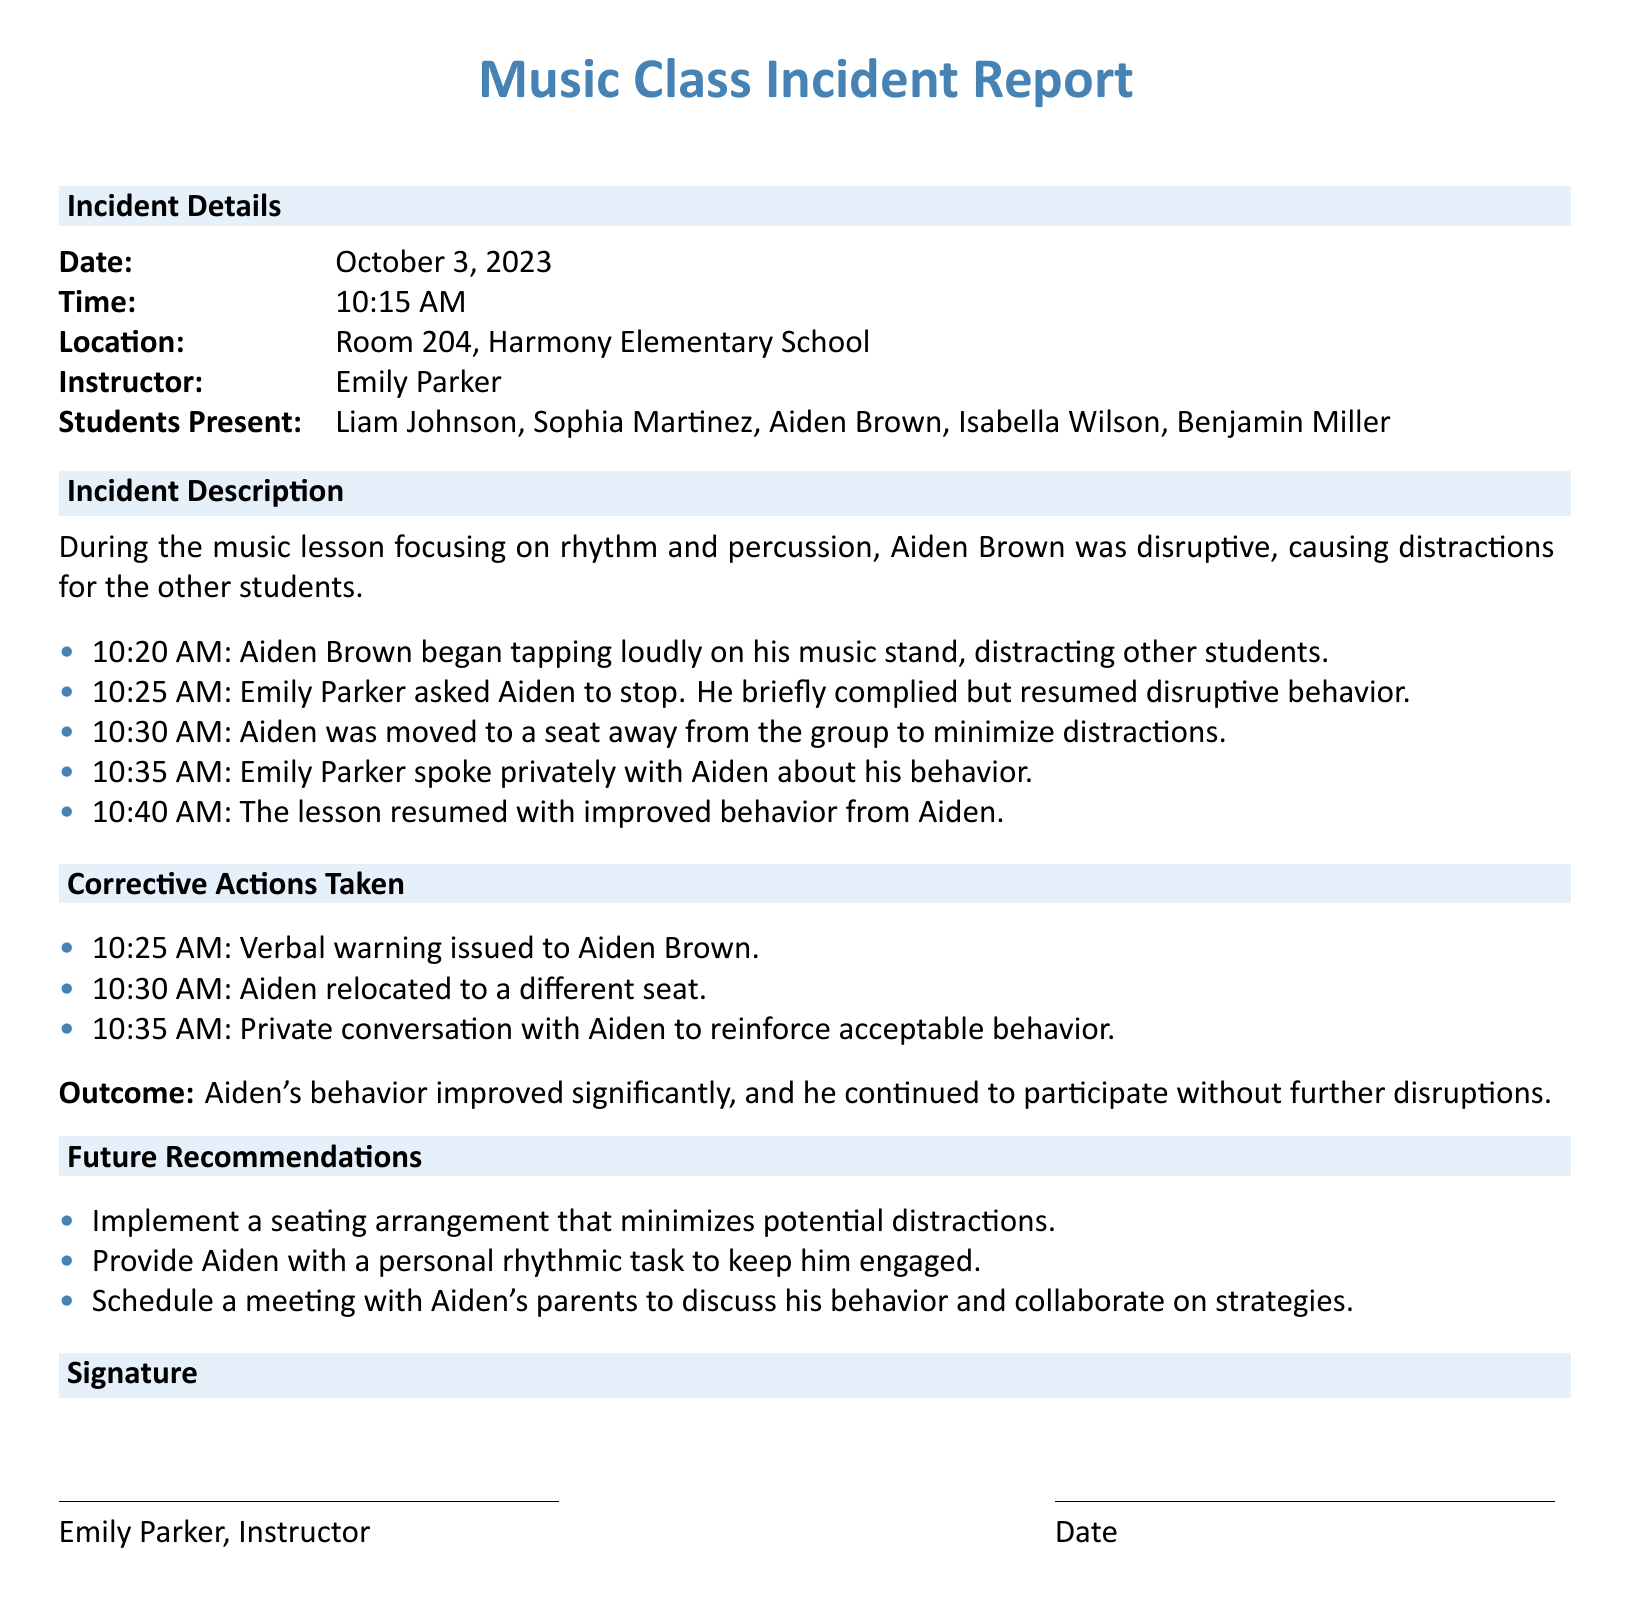What is the date of the incident? The date of the incident is clearly stated in the document under Incident Details.
Answer: October 3, 2023 Who was the instructor during the music class? The instructor's name is provided in the Incident Details section of the report.
Answer: Emily Parker What disruptive behavior did Aiden engage in? The document specifies the disruptive action taken by Aiden during the music lesson.
Answer: Tapping loudly on his music stand At what time was Aiden moved to a different seat? The time when the seating change occurred is listed in the timeline of the incident.
Answer: 10:30 AM What was one corrective action taken regarding Aiden's behavior? The report details specific actions taken to address the disruptive behavior of Aiden.
Answer: Verbal warning issued What was the outcome of Aiden's behavior after the corrective actions? The outcome of Aiden's behavior is described in the conclusion of the report.
Answer: Improved significantly What recommendations are made for future actions? Future recommendations section discusses potential strategies to prevent similar incidents.
Answer: Implement a seating arrangement that minimizes potential distractions What time did the instructor initially ask Aiden to stop his disruptive behavior? The time when the request was made is documented in the sequence of events during the incident.
Answer: 10:25 AM 